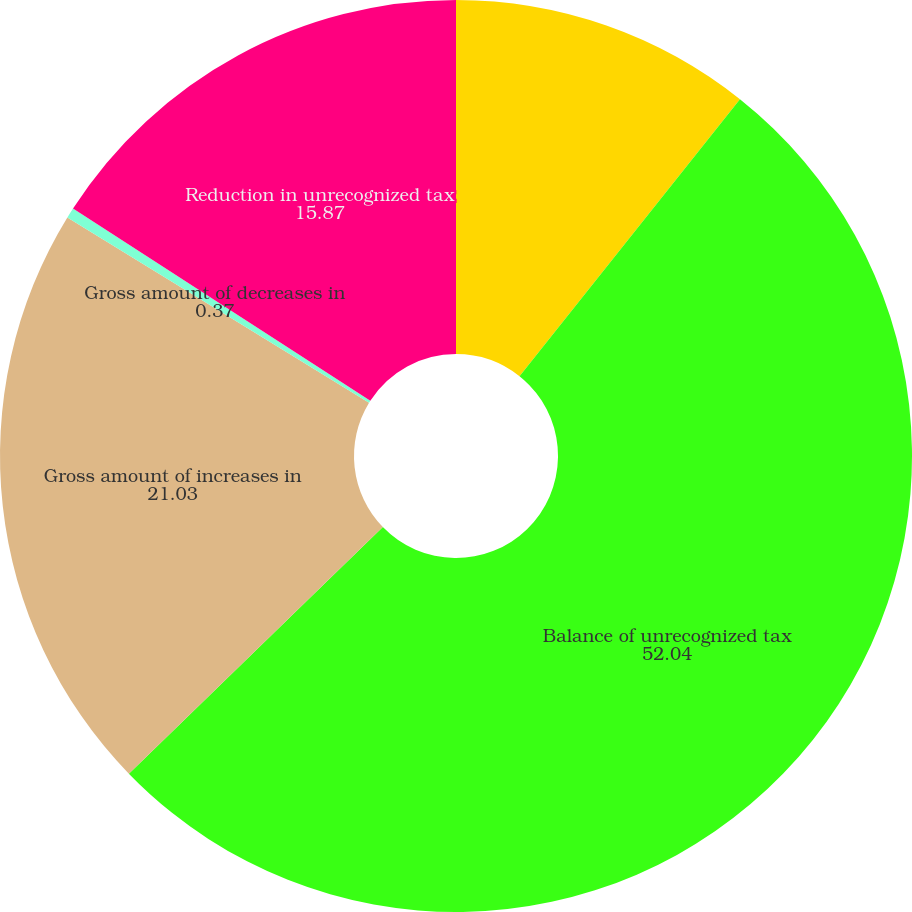<chart> <loc_0><loc_0><loc_500><loc_500><pie_chart><fcel>(DOLLARS IN THOUSANDS)<fcel>Balance of unrecognized tax<fcel>Gross amount of increases in<fcel>Gross amount of decreases in<fcel>Reduction in unrecognized tax<nl><fcel>10.7%<fcel>52.04%<fcel>21.03%<fcel>0.37%<fcel>15.87%<nl></chart> 